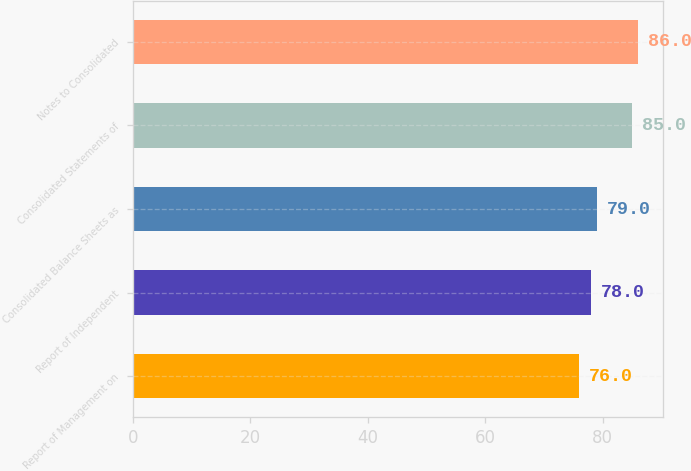<chart> <loc_0><loc_0><loc_500><loc_500><bar_chart><fcel>Report of Management on<fcel>Report of Independent<fcel>Consolidated Balance Sheets as<fcel>Consolidated Statements of<fcel>Notes to Consolidated<nl><fcel>76<fcel>78<fcel>79<fcel>85<fcel>86<nl></chart> 